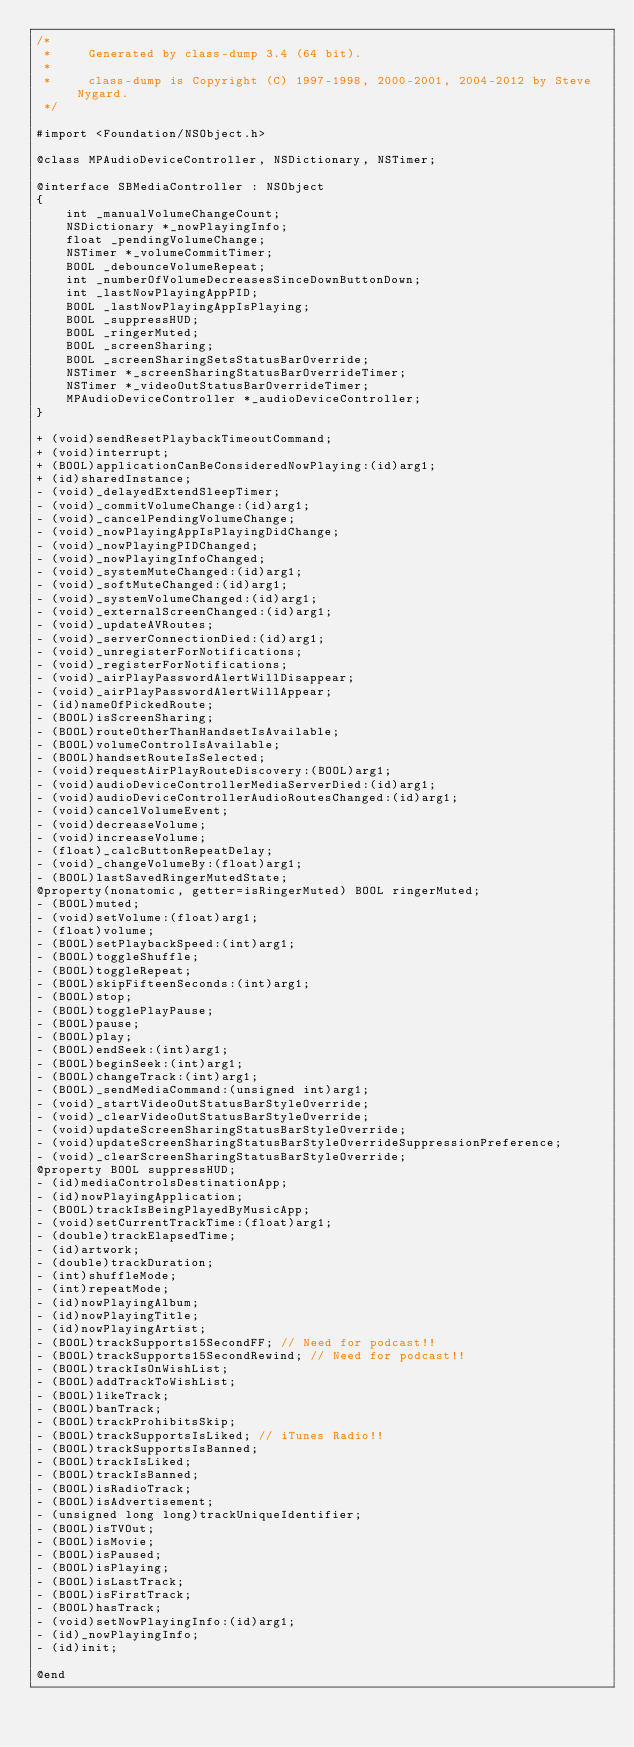<code> <loc_0><loc_0><loc_500><loc_500><_C_>/*
 *     Generated by class-dump 3.4 (64 bit).
 *
 *     class-dump is Copyright (C) 1997-1998, 2000-2001, 2004-2012 by Steve Nygard.
 */

#import <Foundation/NSObject.h>

@class MPAudioDeviceController, NSDictionary, NSTimer;

@interface SBMediaController : NSObject
{
    int _manualVolumeChangeCount;
    NSDictionary *_nowPlayingInfo;
    float _pendingVolumeChange;
    NSTimer *_volumeCommitTimer;
    BOOL _debounceVolumeRepeat;
    int _numberOfVolumeDecreasesSinceDownButtonDown;
    int _lastNowPlayingAppPID;
    BOOL _lastNowPlayingAppIsPlaying;
    BOOL _suppressHUD;
    BOOL _ringerMuted;
    BOOL _screenSharing;
    BOOL _screenSharingSetsStatusBarOverride;
    NSTimer *_screenSharingStatusBarOverrideTimer;
    NSTimer *_videoOutStatusBarOverrideTimer;
    MPAudioDeviceController *_audioDeviceController;
}

+ (void)sendResetPlaybackTimeoutCommand;
+ (void)interrupt;
+ (BOOL)applicationCanBeConsideredNowPlaying:(id)arg1;
+ (id)sharedInstance;
- (void)_delayedExtendSleepTimer;
- (void)_commitVolumeChange:(id)arg1;
- (void)_cancelPendingVolumeChange;
- (void)_nowPlayingAppIsPlayingDidChange;
- (void)_nowPlayingPIDChanged;
- (void)_nowPlayingInfoChanged;
- (void)_systemMuteChanged:(id)arg1;
- (void)_softMuteChanged:(id)arg1;
- (void)_systemVolumeChanged:(id)arg1;
- (void)_externalScreenChanged:(id)arg1;
- (void)_updateAVRoutes;
- (void)_serverConnectionDied:(id)arg1;
- (void)_unregisterForNotifications;
- (void)_registerForNotifications;
- (void)_airPlayPasswordAlertWillDisappear;
- (void)_airPlayPasswordAlertWillAppear;
- (id)nameOfPickedRoute;
- (BOOL)isScreenSharing;
- (BOOL)routeOtherThanHandsetIsAvailable;
- (BOOL)volumeControlIsAvailable;
- (BOOL)handsetRouteIsSelected;
- (void)requestAirPlayRouteDiscovery:(BOOL)arg1;
- (void)audioDeviceControllerMediaServerDied:(id)arg1;
- (void)audioDeviceControllerAudioRoutesChanged:(id)arg1;
- (void)cancelVolumeEvent;
- (void)decreaseVolume;
- (void)increaseVolume;
- (float)_calcButtonRepeatDelay;
- (void)_changeVolumeBy:(float)arg1;
- (BOOL)lastSavedRingerMutedState;
@property(nonatomic, getter=isRingerMuted) BOOL ringerMuted;
- (BOOL)muted;
- (void)setVolume:(float)arg1;
- (float)volume;
- (BOOL)setPlaybackSpeed:(int)arg1;
- (BOOL)toggleShuffle;
- (BOOL)toggleRepeat;
- (BOOL)skipFifteenSeconds:(int)arg1;
- (BOOL)stop;
- (BOOL)togglePlayPause;
- (BOOL)pause;
- (BOOL)play;
- (BOOL)endSeek:(int)arg1;
- (BOOL)beginSeek:(int)arg1;
- (BOOL)changeTrack:(int)arg1;
- (BOOL)_sendMediaCommand:(unsigned int)arg1;
- (void)_startVideoOutStatusBarStyleOverride;
- (void)_clearVideoOutStatusBarStyleOverride;
- (void)updateScreenSharingStatusBarStyleOverride;
- (void)updateScreenSharingStatusBarStyleOverrideSuppressionPreference;
- (void)_clearScreenSharingStatusBarStyleOverride;
@property BOOL suppressHUD;
- (id)mediaControlsDestinationApp;
- (id)nowPlayingApplication;
- (BOOL)trackIsBeingPlayedByMusicApp;
- (void)setCurrentTrackTime:(float)arg1;
- (double)trackElapsedTime;
- (id)artwork;
- (double)trackDuration;
- (int)shuffleMode;
- (int)repeatMode;
- (id)nowPlayingAlbum;
- (id)nowPlayingTitle;
- (id)nowPlayingArtist;
- (BOOL)trackSupports15SecondFF; // Need for podcast!!
- (BOOL)trackSupports15SecondRewind; // Need for podcast!!
- (BOOL)trackIsOnWishList;
- (BOOL)addTrackToWishList;
- (BOOL)likeTrack;
- (BOOL)banTrack;
- (BOOL)trackProhibitsSkip;
- (BOOL)trackSupportsIsLiked; // iTunes Radio!!
- (BOOL)trackSupportsIsBanned;
- (BOOL)trackIsLiked;
- (BOOL)trackIsBanned;
- (BOOL)isRadioTrack;
- (BOOL)isAdvertisement;
- (unsigned long long)trackUniqueIdentifier;
- (BOOL)isTVOut;
- (BOOL)isMovie;
- (BOOL)isPaused;
- (BOOL)isPlaying;
- (BOOL)isLastTrack;
- (BOOL)isFirstTrack;
- (BOOL)hasTrack;
- (void)setNowPlayingInfo:(id)arg1;
- (id)_nowPlayingInfo;
- (id)init;

@end

</code> 